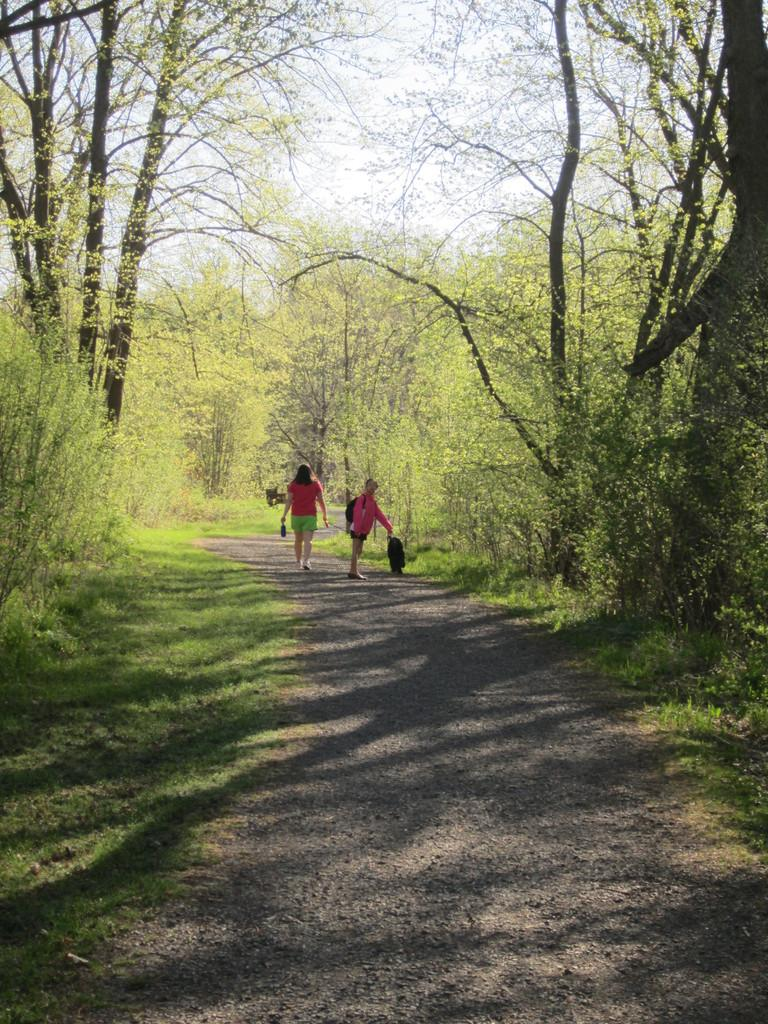What can be seen on the ground in the image? There are people on the path in the image. What object is visible in the image that might be used for carrying items? There is a bag visible in the image. What type of vegetation is present in the image? There is grass in the image. What else can be seen in the image besides the people and the bag? There are trees in the image. What is visible in the background of the image? The sky is visible in the background of the image. Can you tell me how many people are kissing in the image? There is no kissing depicted in the image; it features people walking on a path with a bag and surrounded by grass, trees, and the sky. What type of relation do the people in the image have with each other? The image does not provide any information about the relationship between the people; they are simply walking on a path. 